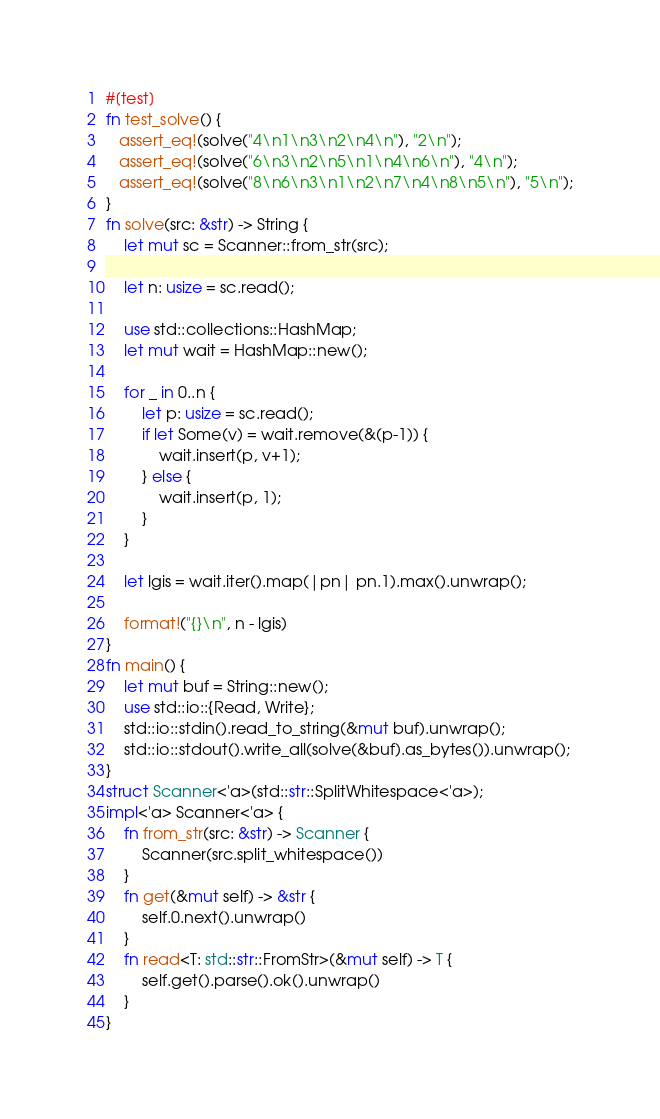<code> <loc_0><loc_0><loc_500><loc_500><_Rust_>#[test]
fn test_solve() {
   assert_eq!(solve("4\n1\n3\n2\n4\n"), "2\n");
   assert_eq!(solve("6\n3\n2\n5\n1\n4\n6\n"), "4\n");
   assert_eq!(solve("8\n6\n3\n1\n2\n7\n4\n8\n5\n"), "5\n");
}
fn solve(src: &str) -> String {
    let mut sc = Scanner::from_str(src);

    let n: usize = sc.read();
    
    use std::collections::HashMap;
    let mut wait = HashMap::new();

    for _ in 0..n {
        let p: usize = sc.read();
        if let Some(v) = wait.remove(&(p-1)) {
            wait.insert(p, v+1);
        } else {
            wait.insert(p, 1);
        }
    }

    let lgis = wait.iter().map(|pn| pn.1).max().unwrap();

    format!("{}\n", n - lgis)
}
fn main() {
    let mut buf = String::new();
    use std::io::{Read, Write};
    std::io::stdin().read_to_string(&mut buf).unwrap();
    std::io::stdout().write_all(solve(&buf).as_bytes()).unwrap();
}
struct Scanner<'a>(std::str::SplitWhitespace<'a>);
impl<'a> Scanner<'a> {
    fn from_str(src: &str) -> Scanner {
        Scanner(src.split_whitespace())
    }
    fn get(&mut self) -> &str {
        self.0.next().unwrap()
    }
    fn read<T: std::str::FromStr>(&mut self) -> T {
        self.get().parse().ok().unwrap()
    }
}</code> 